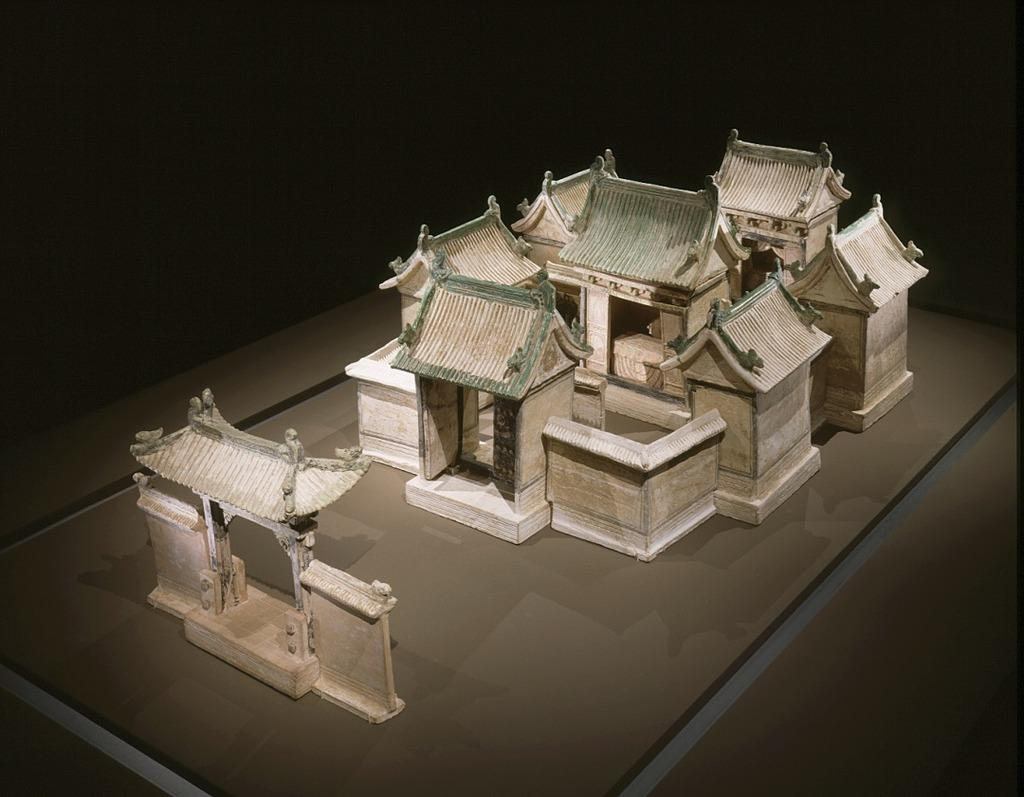What type of structure is depicted in the image? There is a miniature building in the image. How would you describe the overall lighting or color of the image? The background of the image is dark. What other colorful object can be seen in the image? There is a miniature ice cream with color in the image. How many mountains can be seen in the image? There are no mountains present in the image. What type of nail is being used to hold the miniature building together? There is no nail visible in the image, as it features a miniature building and ice cream. 